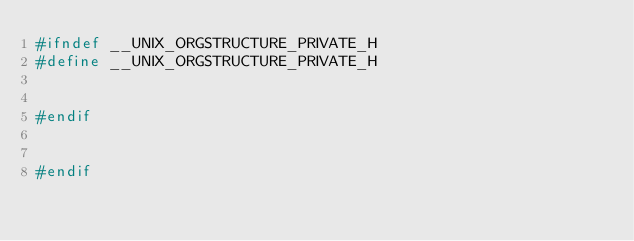Convert code to text. <code><loc_0><loc_0><loc_500><loc_500><_C++_>#ifndef __UNIX_ORGSTRUCTURE_PRIVATE_H
#define __UNIX_ORGSTRUCTURE_PRIVATE_H


#endif


#endif
</code> 